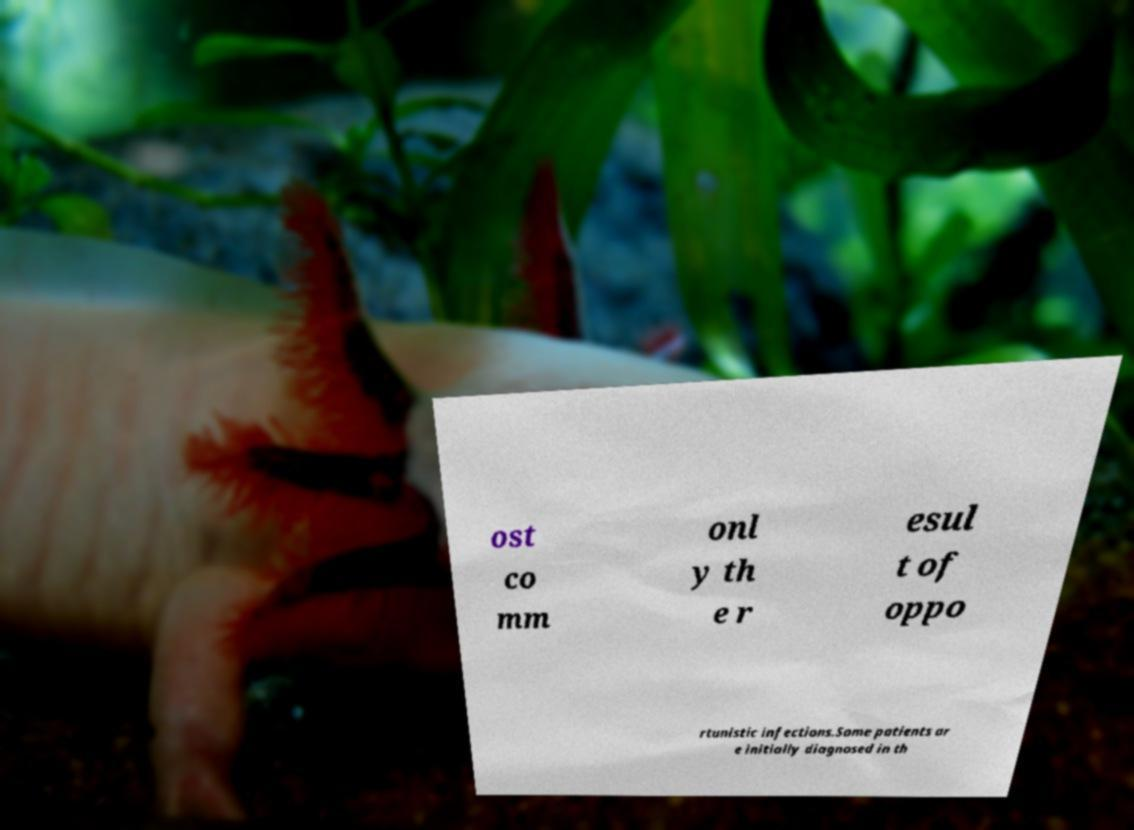Please identify and transcribe the text found in this image. ost co mm onl y th e r esul t of oppo rtunistic infections.Some patients ar e initially diagnosed in th 